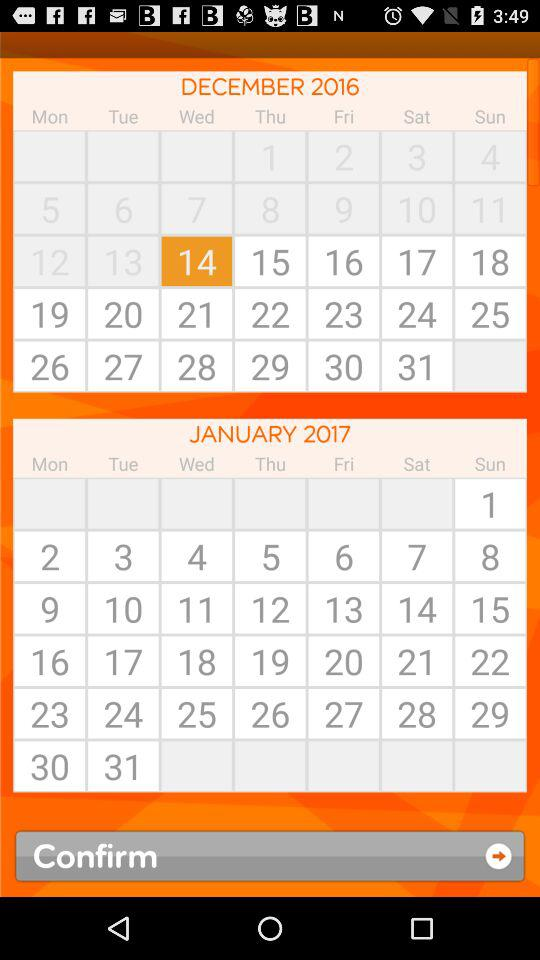What is the current date? The current date is Wednesday, December 14, 2016. 